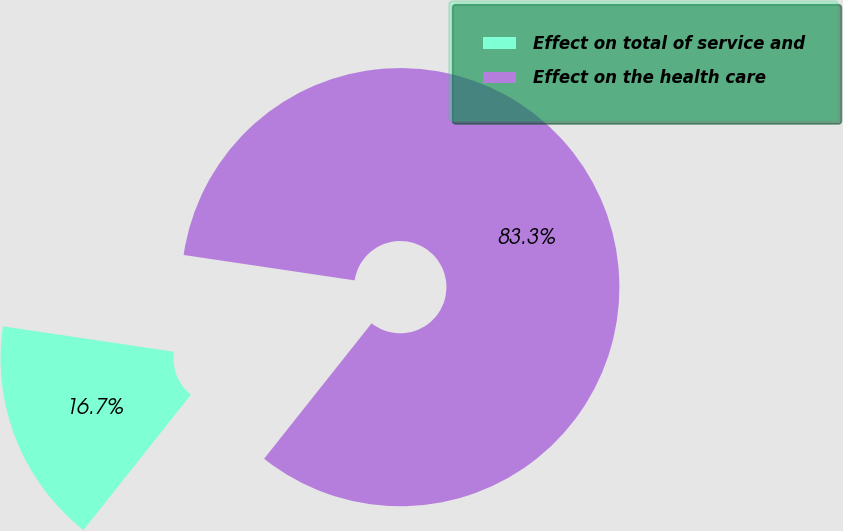Convert chart to OTSL. <chart><loc_0><loc_0><loc_500><loc_500><pie_chart><fcel>Effect on total of service and<fcel>Effect on the health care<nl><fcel>16.67%<fcel>83.33%<nl></chart> 